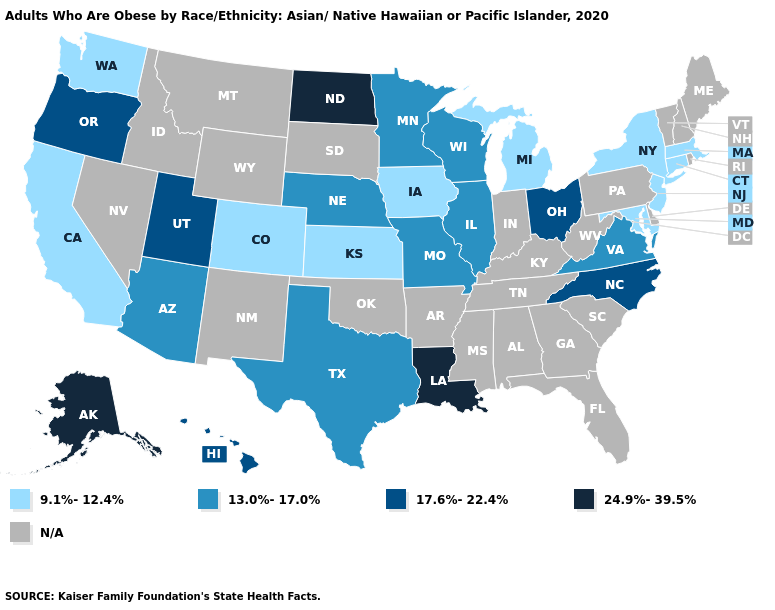What is the highest value in the USA?
Be succinct. 24.9%-39.5%. Name the states that have a value in the range 17.6%-22.4%?
Short answer required. Hawaii, North Carolina, Ohio, Oregon, Utah. What is the highest value in the Northeast ?
Short answer required. 9.1%-12.4%. What is the lowest value in states that border New Mexico?
Quick response, please. 9.1%-12.4%. Name the states that have a value in the range 9.1%-12.4%?
Short answer required. California, Colorado, Connecticut, Iowa, Kansas, Maryland, Massachusetts, Michigan, New Jersey, New York, Washington. Among the states that border Ohio , which have the highest value?
Give a very brief answer. Michigan. Does Wisconsin have the lowest value in the USA?
Concise answer only. No. Is the legend a continuous bar?
Concise answer only. No. Name the states that have a value in the range 13.0%-17.0%?
Write a very short answer. Arizona, Illinois, Minnesota, Missouri, Nebraska, Texas, Virginia, Wisconsin. Which states have the lowest value in the South?
Quick response, please. Maryland. Name the states that have a value in the range 24.9%-39.5%?
Give a very brief answer. Alaska, Louisiana, North Dakota. Among the states that border Nevada , does Utah have the highest value?
Keep it brief. Yes. 